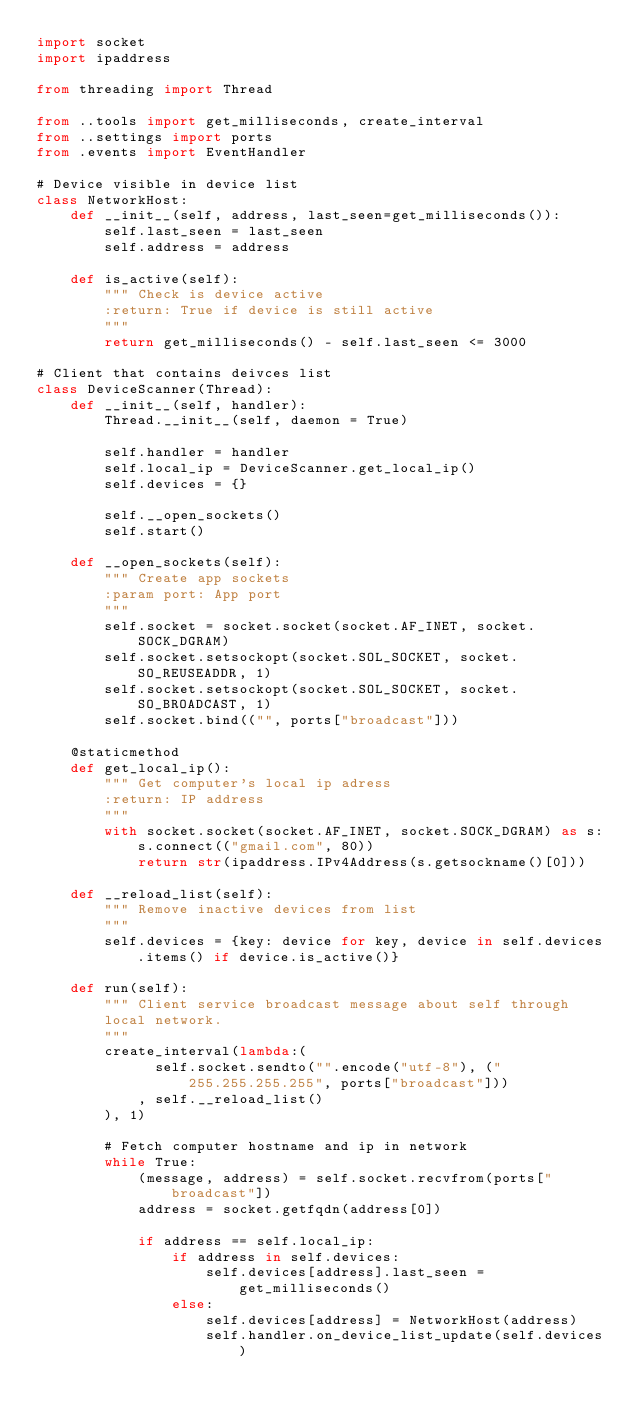Convert code to text. <code><loc_0><loc_0><loc_500><loc_500><_Python_>import socket
import ipaddress

from threading import Thread

from ..tools import get_milliseconds, create_interval
from ..settings import ports
from .events import EventHandler

# Device visible in device list
class NetworkHost:
    def __init__(self, address, last_seen=get_milliseconds()):
        self.last_seen = last_seen
        self.address = address

    def is_active(self):
        """ Check is device active
        :return: True if device is still active
        """
        return get_milliseconds() - self.last_seen <= 3000

# Client that contains deivces list
class DeviceScanner(Thread):
    def __init__(self, handler):
        Thread.__init__(self, daemon = True)

        self.handler = handler
        self.local_ip = DeviceScanner.get_local_ip()
        self.devices = {}

        self.__open_sockets()
        self.start()

    def __open_sockets(self):
        """ Create app sockets
        :param port: App port
        """
        self.socket = socket.socket(socket.AF_INET, socket.SOCK_DGRAM)
        self.socket.setsockopt(socket.SOL_SOCKET, socket.SO_REUSEADDR, 1)
        self.socket.setsockopt(socket.SOL_SOCKET, socket.SO_BROADCAST, 1)
        self.socket.bind(("", ports["broadcast"]))

    @staticmethod
    def get_local_ip():
        """ Get computer's local ip adress
        :return: IP address
        """
        with socket.socket(socket.AF_INET, socket.SOCK_DGRAM) as s:
            s.connect(("gmail.com", 80))
            return str(ipaddress.IPv4Address(s.getsockname()[0]))

    def __reload_list(self):
        """ Remove inactive devices from list
        """
        self.devices = {key: device for key, device in self.devices.items() if device.is_active()}

    def run(self):
        """ Client service broadcast message about self through
        local network.
        """
        create_interval(lambda:(
              self.socket.sendto("".encode("utf-8"), ("255.255.255.255", ports["broadcast"]))
            , self.__reload_list()
        ), 1)

        # Fetch computer hostname and ip in network
        while True:
            (message, address) = self.socket.recvfrom(ports["broadcast"])
            address = socket.getfqdn(address[0])

            if address == self.local_ip:
                if address in self.devices:
                    self.devices[address].last_seen = get_milliseconds()
                else:
                    self.devices[address] = NetworkHost(address)
                    self.handler.on_device_list_update(self.devices)
</code> 